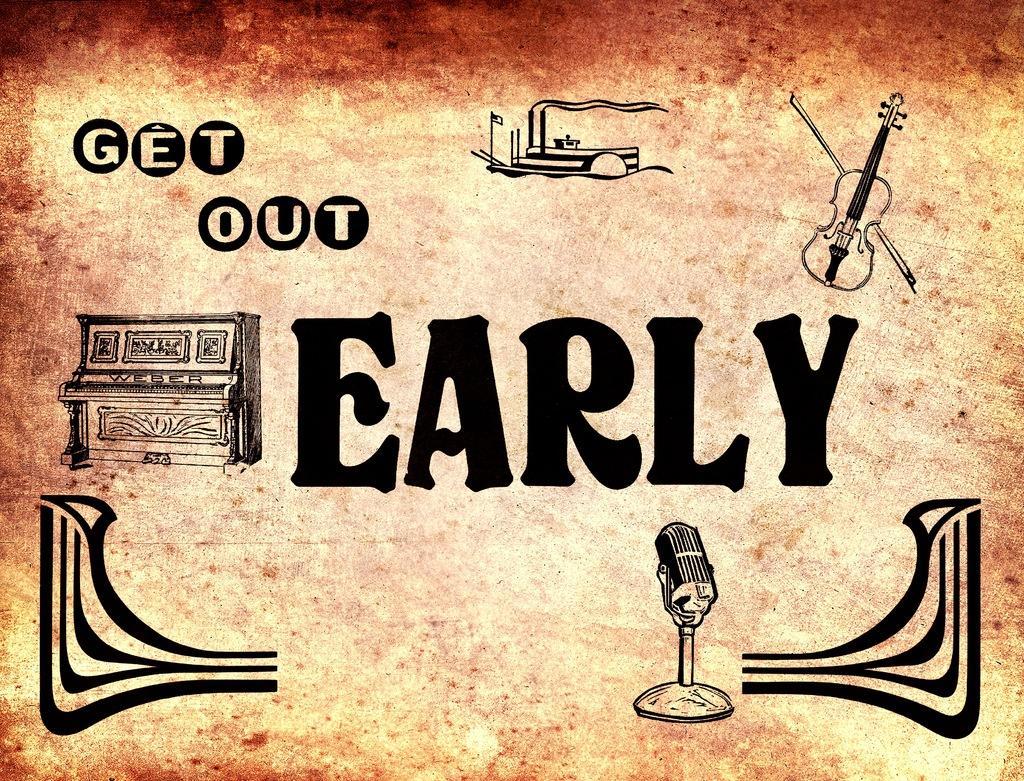Describe this image in one or two sentences. In this image we can see a poster on which there is some text and there is piano, guitar, microphone and some other paintings. 